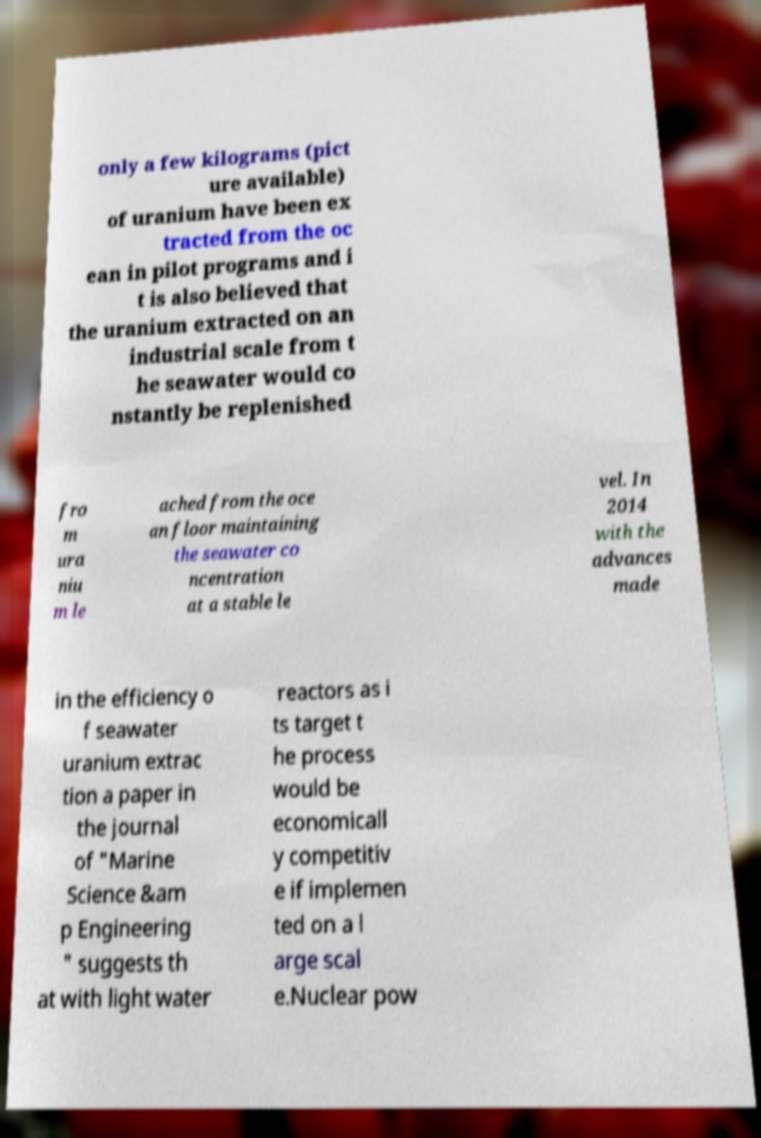Please identify and transcribe the text found in this image. only a few kilograms (pict ure available) of uranium have been ex tracted from the oc ean in pilot programs and i t is also believed that the uranium extracted on an industrial scale from t he seawater would co nstantly be replenished fro m ura niu m le ached from the oce an floor maintaining the seawater co ncentration at a stable le vel. In 2014 with the advances made in the efficiency o f seawater uranium extrac tion a paper in the journal of "Marine Science &am p Engineering " suggests th at with light water reactors as i ts target t he process would be economicall y competitiv e if implemen ted on a l arge scal e.Nuclear pow 